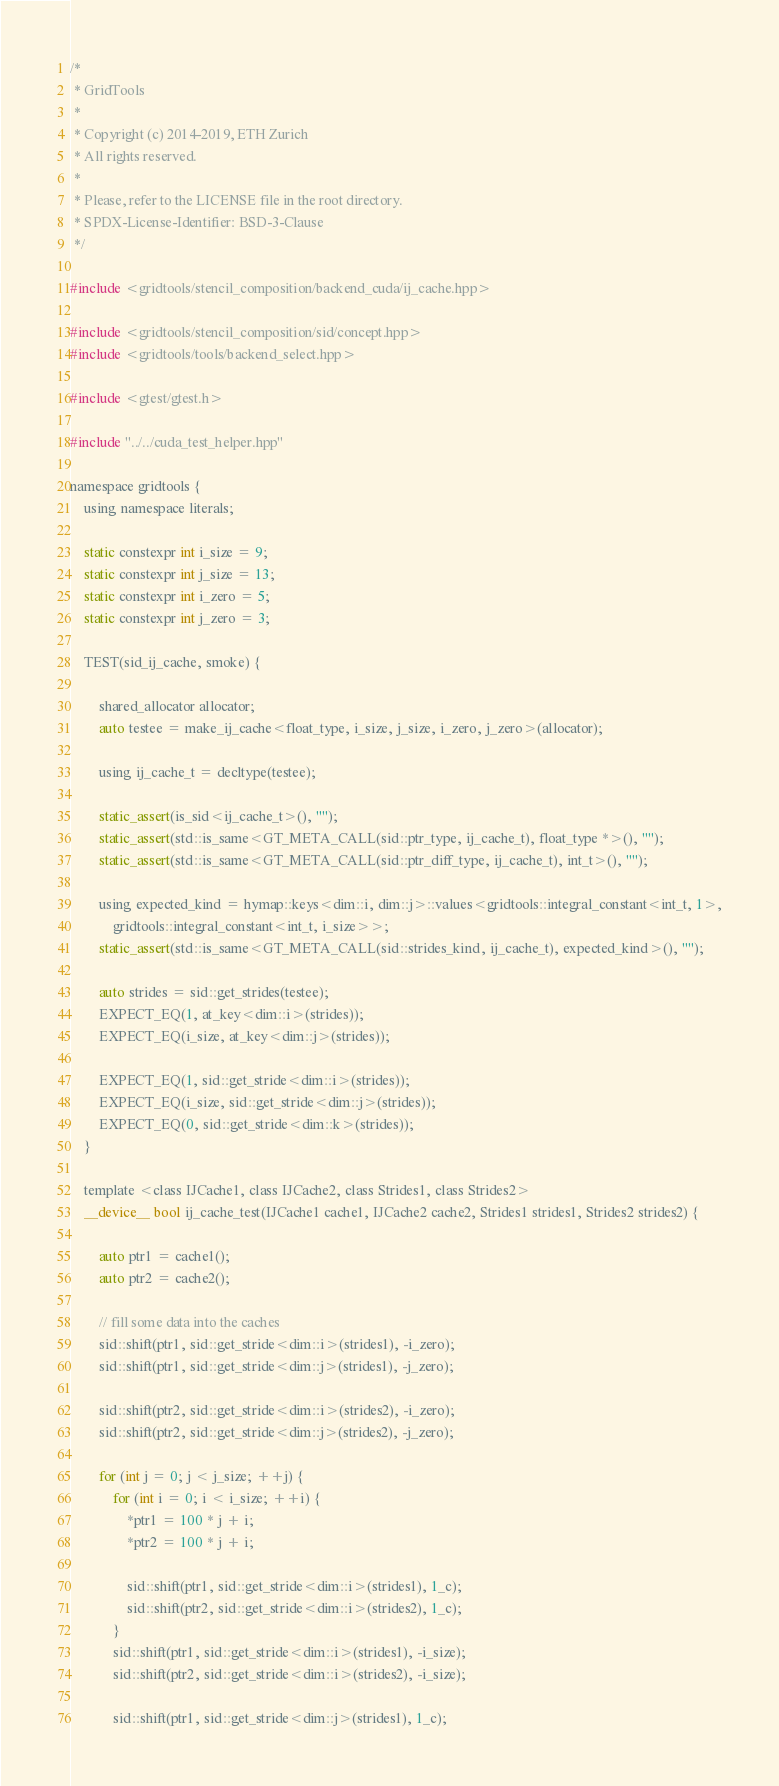<code> <loc_0><loc_0><loc_500><loc_500><_Cuda_>/*
 * GridTools
 *
 * Copyright (c) 2014-2019, ETH Zurich
 * All rights reserved.
 *
 * Please, refer to the LICENSE file in the root directory.
 * SPDX-License-Identifier: BSD-3-Clause
 */

#include <gridtools/stencil_composition/backend_cuda/ij_cache.hpp>

#include <gridtools/stencil_composition/sid/concept.hpp>
#include <gridtools/tools/backend_select.hpp>

#include <gtest/gtest.h>

#include "../../cuda_test_helper.hpp"

namespace gridtools {
    using namespace literals;

    static constexpr int i_size = 9;
    static constexpr int j_size = 13;
    static constexpr int i_zero = 5;
    static constexpr int j_zero = 3;

    TEST(sid_ij_cache, smoke) {

        shared_allocator allocator;
        auto testee = make_ij_cache<float_type, i_size, j_size, i_zero, j_zero>(allocator);

        using ij_cache_t = decltype(testee);

        static_assert(is_sid<ij_cache_t>(), "");
        static_assert(std::is_same<GT_META_CALL(sid::ptr_type, ij_cache_t), float_type *>(), "");
        static_assert(std::is_same<GT_META_CALL(sid::ptr_diff_type, ij_cache_t), int_t>(), "");

        using expected_kind = hymap::keys<dim::i, dim::j>::values<gridtools::integral_constant<int_t, 1>,
            gridtools::integral_constant<int_t, i_size>>;
        static_assert(std::is_same<GT_META_CALL(sid::strides_kind, ij_cache_t), expected_kind>(), "");

        auto strides = sid::get_strides(testee);
        EXPECT_EQ(1, at_key<dim::i>(strides));
        EXPECT_EQ(i_size, at_key<dim::j>(strides));

        EXPECT_EQ(1, sid::get_stride<dim::i>(strides));
        EXPECT_EQ(i_size, sid::get_stride<dim::j>(strides));
        EXPECT_EQ(0, sid::get_stride<dim::k>(strides));
    }

    template <class IJCache1, class IJCache2, class Strides1, class Strides2>
    __device__ bool ij_cache_test(IJCache1 cache1, IJCache2 cache2, Strides1 strides1, Strides2 strides2) {

        auto ptr1 = cache1();
        auto ptr2 = cache2();

        // fill some data into the caches
        sid::shift(ptr1, sid::get_stride<dim::i>(strides1), -i_zero);
        sid::shift(ptr1, sid::get_stride<dim::j>(strides1), -j_zero);

        sid::shift(ptr2, sid::get_stride<dim::i>(strides2), -i_zero);
        sid::shift(ptr2, sid::get_stride<dim::j>(strides2), -j_zero);

        for (int j = 0; j < j_size; ++j) {
            for (int i = 0; i < i_size; ++i) {
                *ptr1 = 100 * j + i;
                *ptr2 = 100 * j + i;

                sid::shift(ptr1, sid::get_stride<dim::i>(strides1), 1_c);
                sid::shift(ptr2, sid::get_stride<dim::i>(strides2), 1_c);
            }
            sid::shift(ptr1, sid::get_stride<dim::i>(strides1), -i_size);
            sid::shift(ptr2, sid::get_stride<dim::i>(strides2), -i_size);

            sid::shift(ptr1, sid::get_stride<dim::j>(strides1), 1_c);</code> 